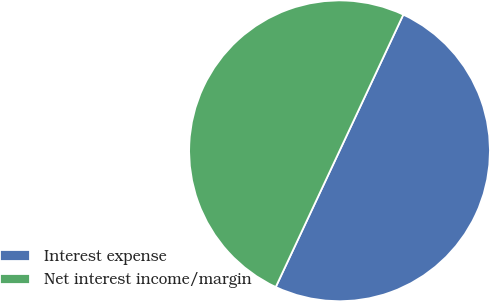Convert chart. <chart><loc_0><loc_0><loc_500><loc_500><pie_chart><fcel>Interest expense<fcel>Net interest income/margin<nl><fcel>50.0%<fcel>50.0%<nl></chart> 